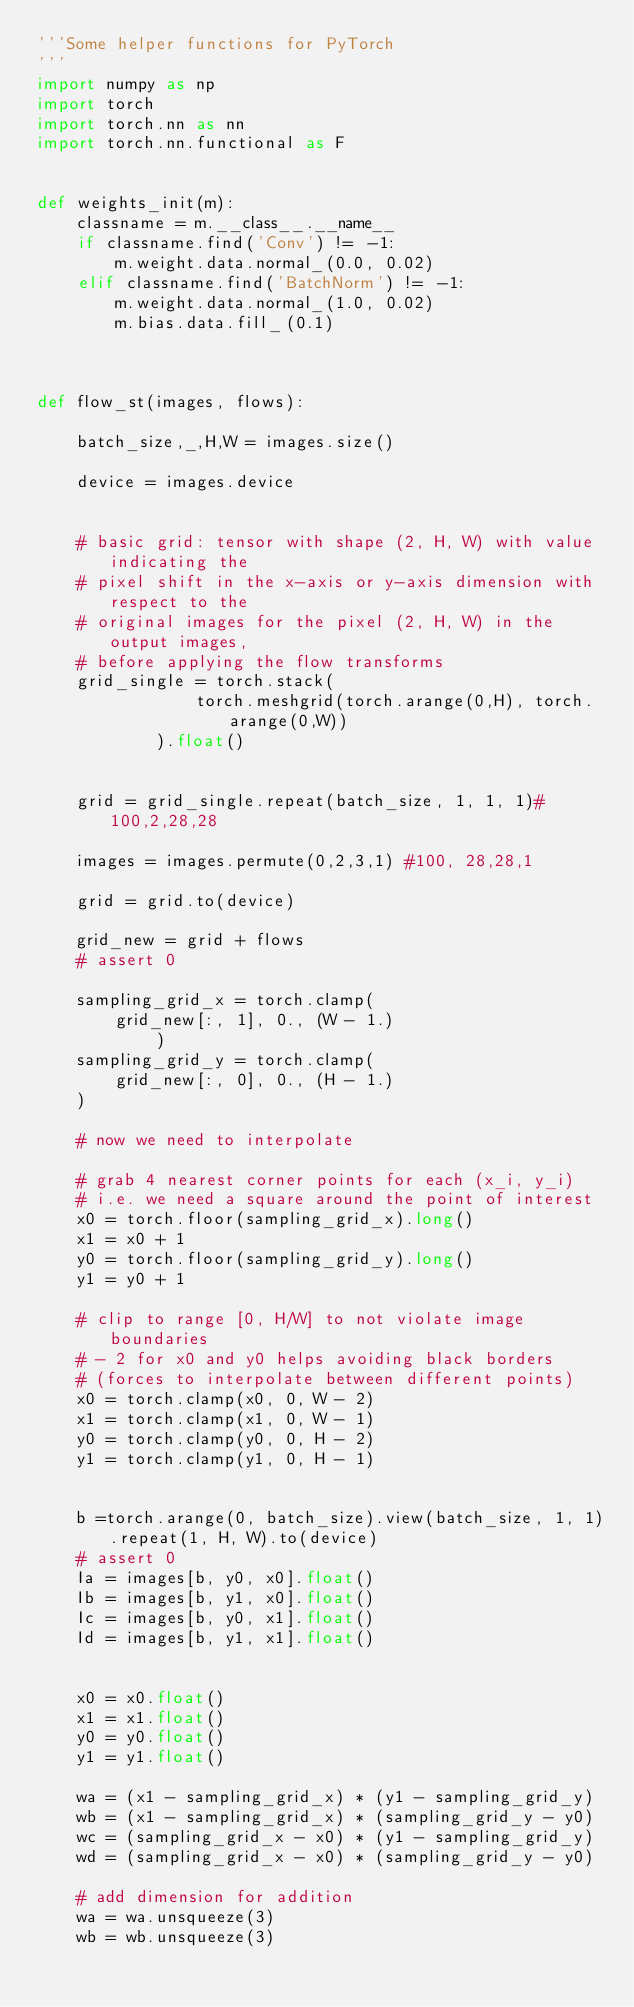<code> <loc_0><loc_0><loc_500><loc_500><_Python_>'''Some helper functions for PyTorch
'''
import numpy as np
import torch
import torch.nn as nn
import torch.nn.functional as F


def weights_init(m):
    classname = m.__class__.__name__
    if classname.find('Conv') != -1:
        m.weight.data.normal_(0.0, 0.02)
    elif classname.find('BatchNorm') != -1:
        m.weight.data.normal_(1.0, 0.02)
        m.bias.data.fill_(0.1)



def flow_st(images, flows):

    batch_size,_,H,W = images.size()

    device = images.device


    # basic grid: tensor with shape (2, H, W) with value indicating the
    # pixel shift in the x-axis or y-axis dimension with respect to the
    # original images for the pixel (2, H, W) in the output images,
    # before applying the flow transforms
    grid_single = torch.stack(
                torch.meshgrid(torch.arange(0,H), torch.arange(0,W))
            ).float()


    grid = grid_single.repeat(batch_size, 1, 1, 1)#100,2,28,28

    images = images.permute(0,2,3,1) #100, 28,28,1

    grid = grid.to(device)

    grid_new = grid + flows
    # assert 0

    sampling_grid_x = torch.clamp(
        grid_new[:, 1], 0., (W - 1.)
            )
    sampling_grid_y = torch.clamp(
        grid_new[:, 0], 0., (H - 1.)
    )
    
    # now we need to interpolate

    # grab 4 nearest corner points for each (x_i, y_i)
    # i.e. we need a square around the point of interest
    x0 = torch.floor(sampling_grid_x).long()
    x1 = x0 + 1
    y0 = torch.floor(sampling_grid_y).long()
    y1 = y0 + 1

    # clip to range [0, H/W] to not violate image boundaries
    # - 2 for x0 and y0 helps avoiding black borders
    # (forces to interpolate between different points)
    x0 = torch.clamp(x0, 0, W - 2)
    x1 = torch.clamp(x1, 0, W - 1)
    y0 = torch.clamp(y0, 0, H - 2)
    y1 = torch.clamp(y1, 0, H - 1)


    b =torch.arange(0, batch_size).view(batch_size, 1, 1).repeat(1, H, W).to(device)
    # assert 0 
    Ia = images[b, y0, x0].float()
    Ib = images[b, y1, x0].float()
    Ic = images[b, y0, x1].float()
    Id = images[b, y1, x1].float()


    x0 = x0.float()
    x1 = x1.float()
    y0 = y0.float()
    y1 = y1.float()

    wa = (x1 - sampling_grid_x) * (y1 - sampling_grid_y)
    wb = (x1 - sampling_grid_x) * (sampling_grid_y - y0)
    wc = (sampling_grid_x - x0) * (y1 - sampling_grid_y)
    wd = (sampling_grid_x - x0) * (sampling_grid_y - y0)

    # add dimension for addition
    wa = wa.unsqueeze(3)
    wb = wb.unsqueeze(3)</code> 